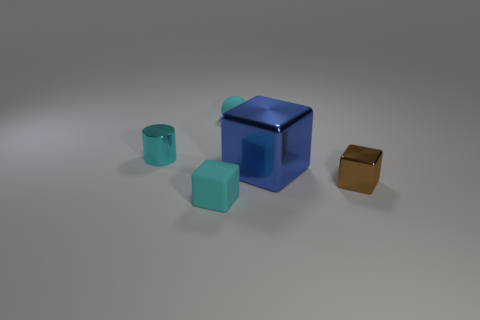Is the color of the tiny ball the same as the small shiny object that is left of the large metallic block? Yes, the color of the tiny ball closely matches the hue of the small shiny object situated to the left of the large metallic block, both displaying shades of a soft turquoise. 